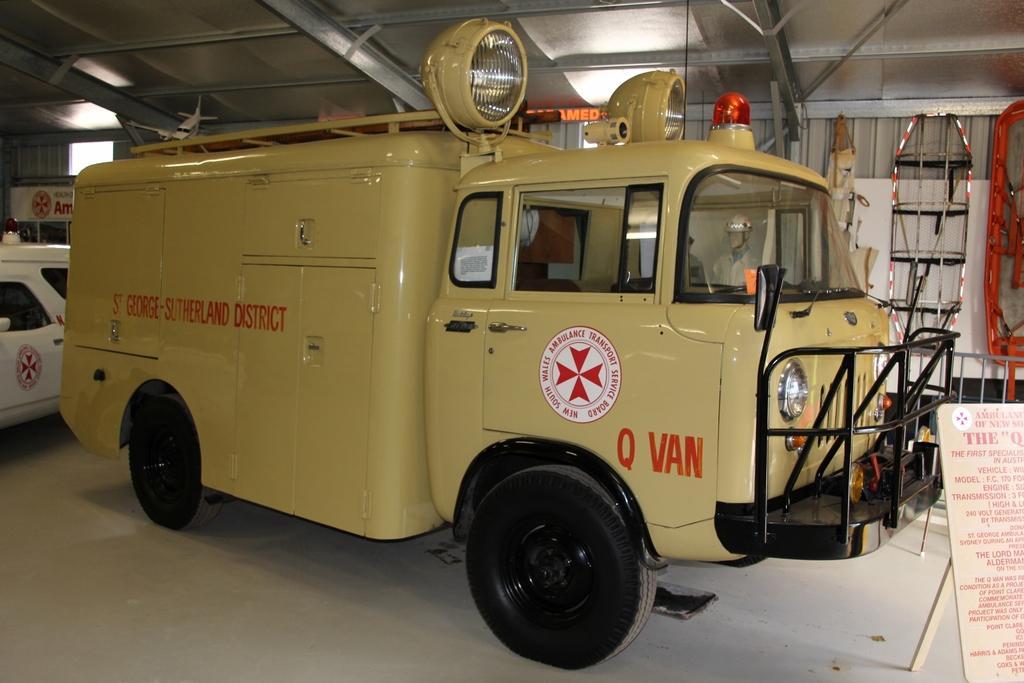How would you summarize this image in a sentence or two? It is a van, it has headlights and orange color light on the top of it. On the right side there is a board with matter in red color. 